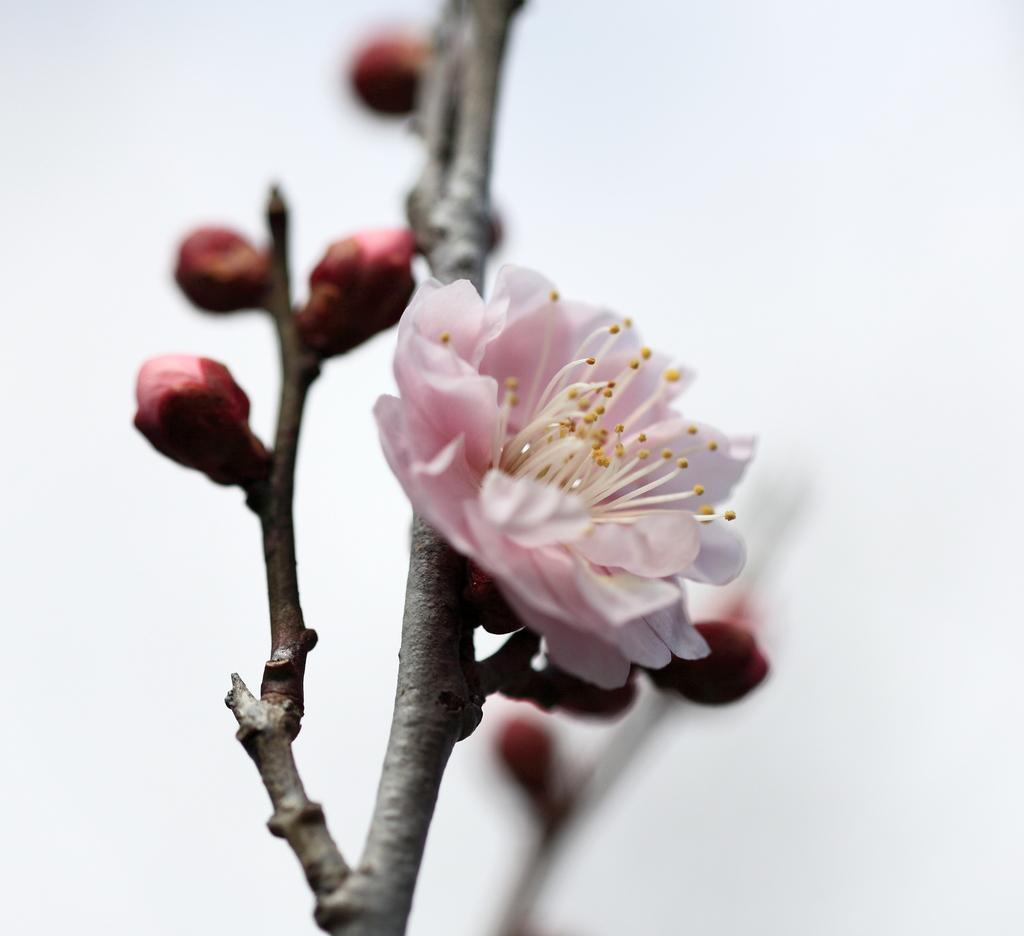What is the main subject of the image? There is a flower in the image. Can you describe any other features of the flower? There are a few buds in the image. What color is the background of the image? The background of the image is white. Can you tell me how many geese are flying in the image? There are no geese present in the image; it features a flower and buds. What type of cave can be seen in the background of the image? There is no cave present in the image; the background is white. 